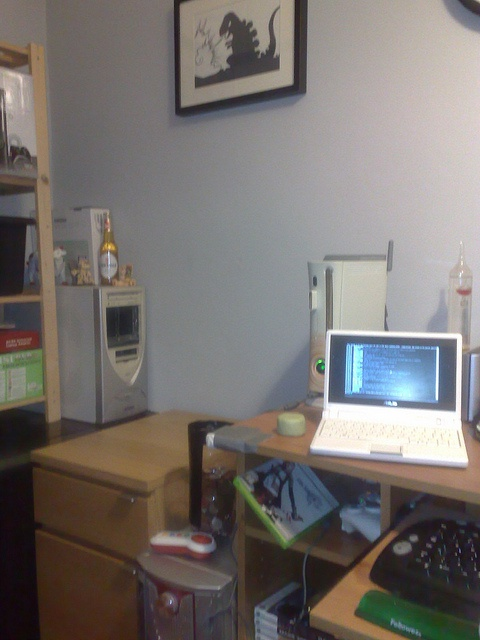Describe the objects in this image and their specific colors. I can see laptop in gray, white, and lightblue tones, keyboard in gray and black tones, keyboard in gray, ivory, lightgray, and darkgray tones, bottle in gray, darkgray, and lightgray tones, and bottle in gray tones in this image. 